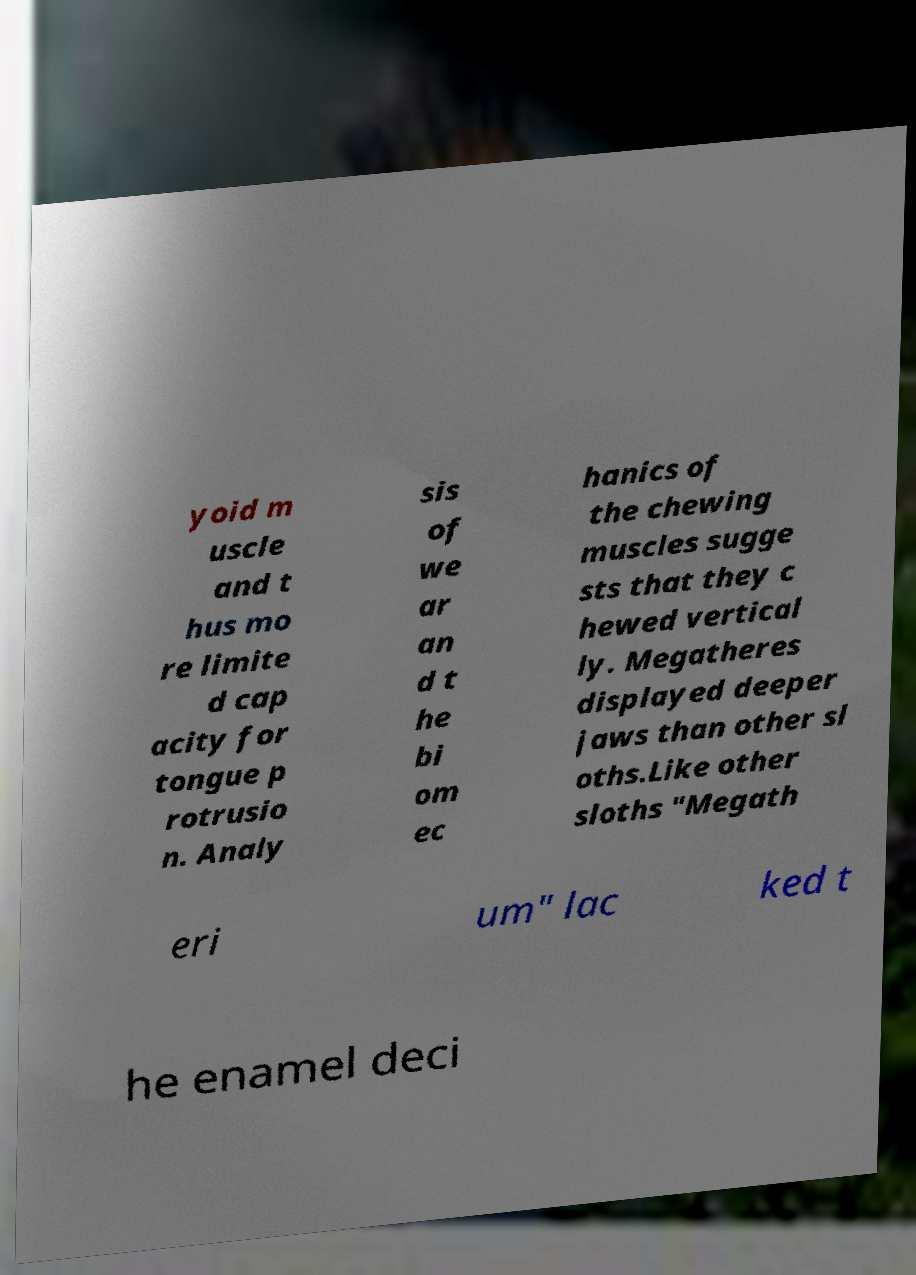Can you accurately transcribe the text from the provided image for me? yoid m uscle and t hus mo re limite d cap acity for tongue p rotrusio n. Analy sis of we ar an d t he bi om ec hanics of the chewing muscles sugge sts that they c hewed vertical ly. Megatheres displayed deeper jaws than other sl oths.Like other sloths "Megath eri um" lac ked t he enamel deci 